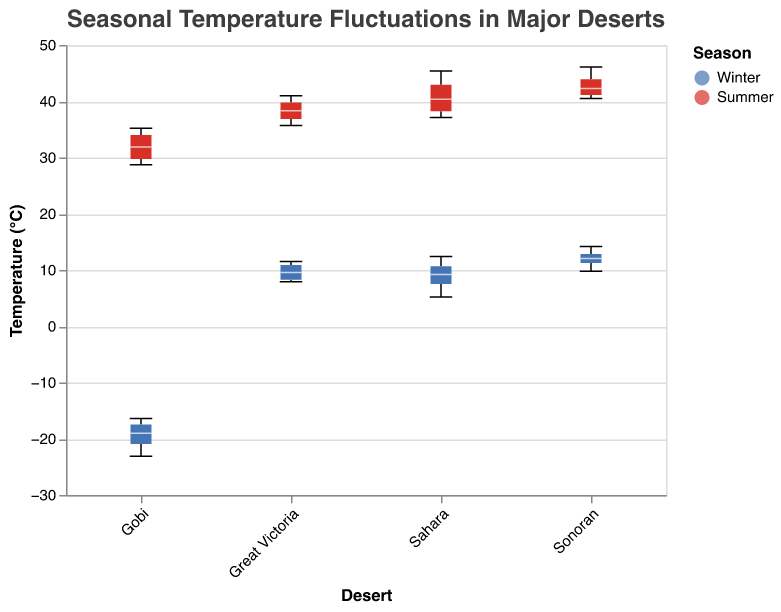How many temperature data points are there for each season in the Sahara desert? Count the number of temperature data points for Winter and Summer in the Sahara desert by looking at the length of the boxes and the ticks. For Winter, there are 4 data points, and for Summer, there are also 4 data points.
Answer: 4 for each season Which desert has the highest median temperature in Summer? Identify the median markers (white lines) in the Summer boxes for each desert. The Sonoran desert has the highest median temperature in Summer.
Answer: Sonoran What is the median Winter temperature in the Gobi desert? Find the median marker (white line) on the Winter box for the Gobi desert. The median winter temperature appears to be around -20.2°C.
Answer: -20.2°C How does the interquartile range (IQR) of Winter temperatures compare between the Sahara and the Sonoran deserts? For each desert, find the range between the top and bottom of the box in Winter. The Sahara has a wider IQR than the Sonoran desert, indicating more variability in Winter temperatures.
Answer: Sahara has a wider IQR Which desert shows the largest temperature range in Summer? Compare the extent (whiskers) of the boxes in Summer. The Sonoran desert has the largest temperature range in Summer.
Answer: Sonoran Is there any overlap in Winter temperatures between the Sahara and Great Victoria deserts? Look for overlap between the notches of the Winter boxes for the Sahara and Great Victoria deserts. There is an overlap, indicating that their median temperatures are not significantly different.
Answer: Yes Which desert has the lowest summer temperature recorded? Identify the minimum point on the Summer boxes for each desert. The Gobi desert has the lowest recorded summer temperature.
Answer: Gobi What is the approximate range of Winter temperatures in the Great Victoria desert? Determine the minimum and maximum values by looking at the whiskers of the Winter box for the Great Victoria desert. The range is between 7.9°C and 11.5°C.
Answer: 7.9°C to 11.5°C Compare the median Summer temperatures of the Sahara and Great Victoria deserts. Find the median markers (white lines) in the Summer boxes for both deserts. The Sahara has a slightly higher median Summer temperature compared to Great Victoria.
Answer: Sahara is higher How does the variability of Winter temperatures in the Gobi desert compare to other deserts? Assess the length of the Winter boxes (IQR) and whiskers (range) for each desert. The Gobi desert shows the highest variability with temperatures ranging from -23.1°C to -16.4°C and a wide IQR.
Answer: Gobi has the highest variability 